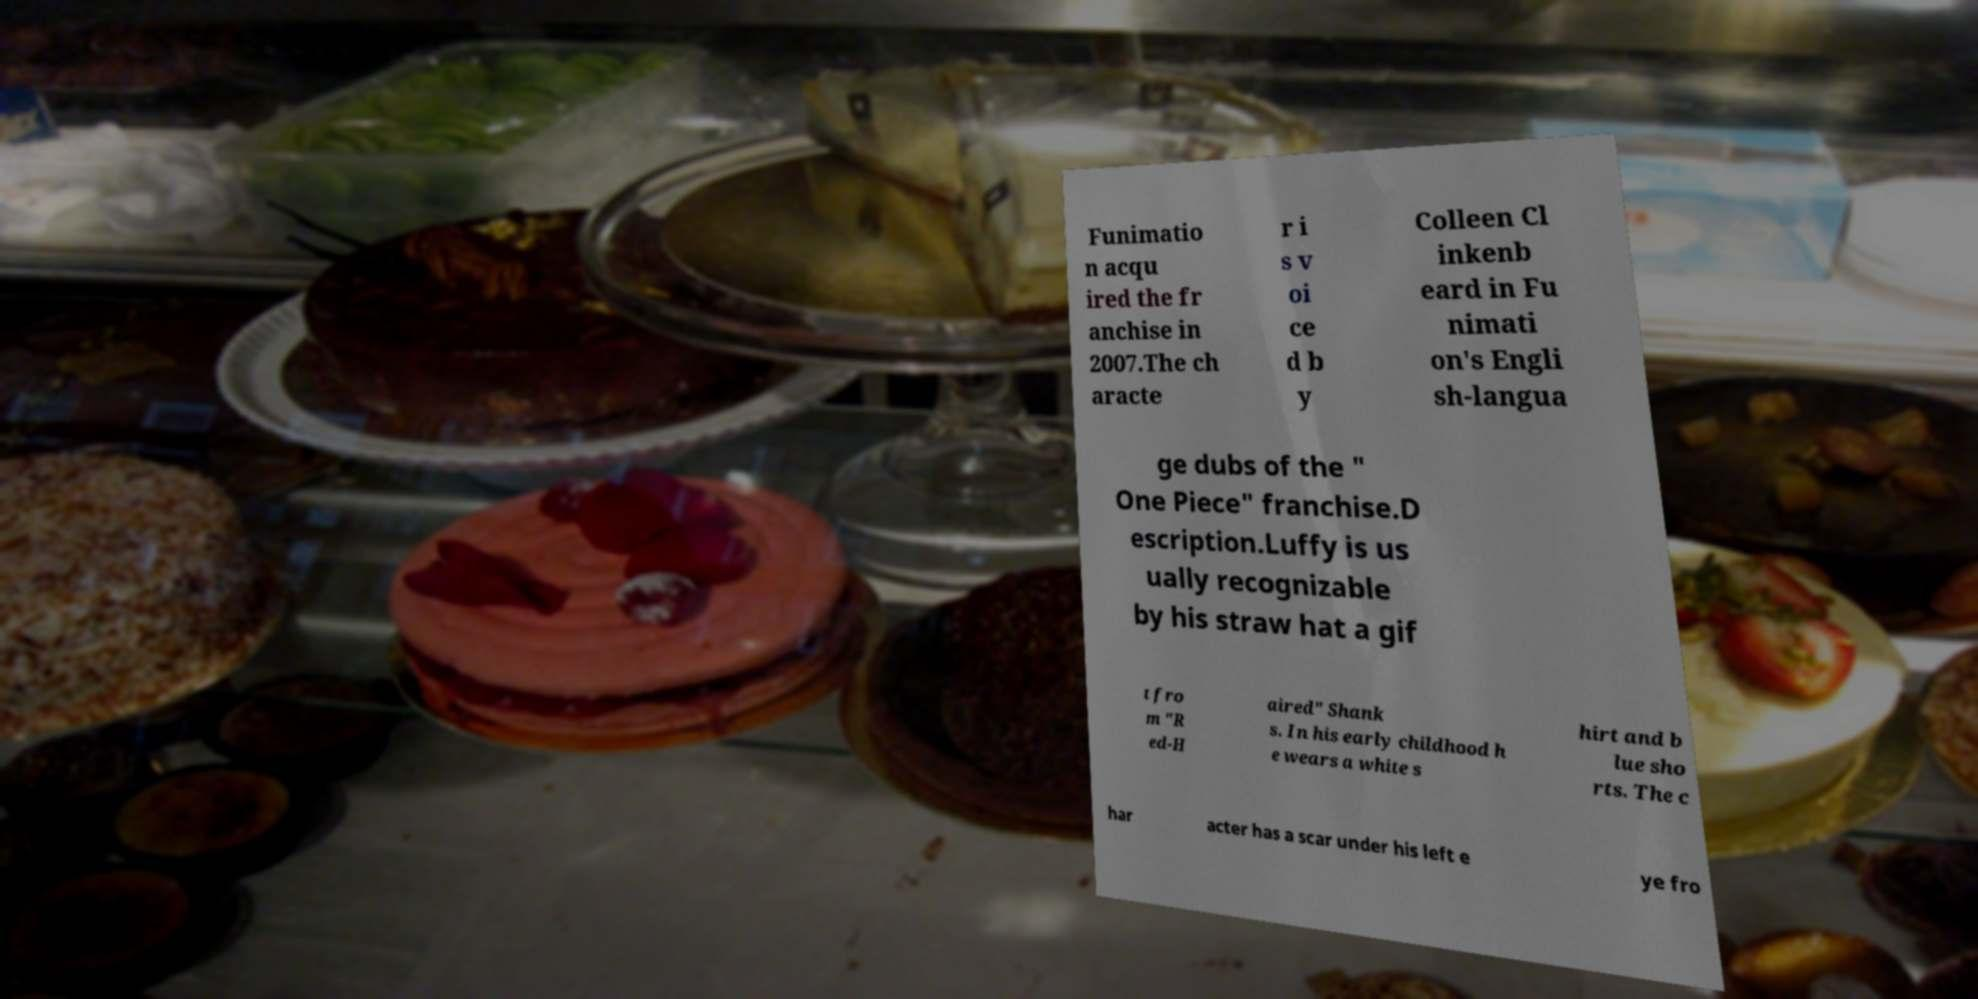Please identify and transcribe the text found in this image. Funimatio n acqu ired the fr anchise in 2007.The ch aracte r i s v oi ce d b y Colleen Cl inkenb eard in Fu nimati on's Engli sh-langua ge dubs of the " One Piece" franchise.D escription.Luffy is us ually recognizable by his straw hat a gif t fro m "R ed-H aired" Shank s. In his early childhood h e wears a white s hirt and b lue sho rts. The c har acter has a scar under his left e ye fro 